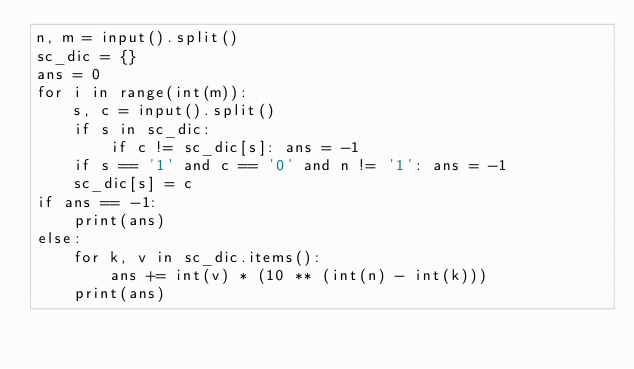<code> <loc_0><loc_0><loc_500><loc_500><_Python_>n, m = input().split()
sc_dic = {}
ans = 0
for i in range(int(m)):
    s, c = input().split()
    if s in sc_dic:
        if c != sc_dic[s]: ans = -1
    if s == '1' and c == '0' and n != '1': ans = -1
    sc_dic[s] = c
if ans == -1:
    print(ans)
else:
    for k, v in sc_dic.items():
        ans += int(v) * (10 ** (int(n) - int(k)))
    print(ans)</code> 